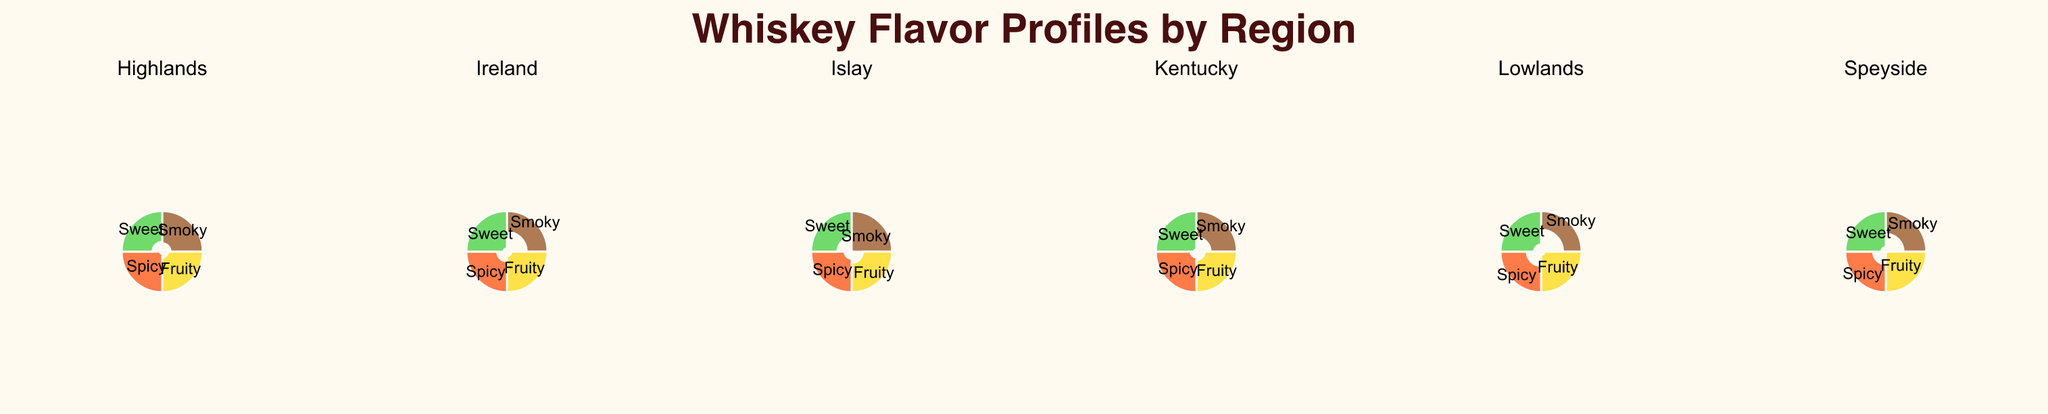Which region has the highest score for the 'Smoky' flavor? By examining the 'Smoky' section in each subplot, the region with the highest radius appears to be Islay with a score of 95.
Answer: Islay Which region shows the most balanced flavor profile, where scores across all flavors are closest to each other? The region with the most balanced flavor profile will have the radii of all flavors closest in length. Upon reviewing the polar charts, Ireland has the most balanced profile with scores relatively close (Smoky: 25, Fruity: 75, Spicy: 55, Sweet: 80).
Answer: Ireland What is the average score for fruity flavors across all regions? First, identify the scores for fruity flavors in each region: Islay: 50, Speyside: 90, Highlands: 70, Lowlands: 80, Kentucky: 60, Ireland: 75. Sum these scores (50 + 90 + 70 + 80 + 60 + 75 = 425). Then, divide by the number of regions (425/6 = 70.83).
Answer: 70.83 Which flavor has the highest average score across all regions? Sum up the scores for each flavor across all regions and divide by the number of regions: Smoky: (95+30+60+20+40+25)/6 = 45, Fruity: (50+90+70+80+60+75)/6 = 70.83, Spicy: (65+45+85+40+70+55)/6 = 60, Sweet: (40+75+55+65+85+80)/6 = 66.67. The highest average is the fruity flavor.
Answer: Fruity Which region has the lowest score for the 'Sweet' flavor? By looking at the 'Sweet' section in each subplot, Islay has the smallest radius for the 'Sweet' flavor with a score of 40.
Answer: Islay What is the total score for the 'Spicy' flavor across all regions? Sum the scores for the 'Spicy' flavor in each region: Islay: 65, Speyside: 45, Highlands: 85, Lowlands: 40, Kentucky: 70, Ireland: 55. The total is 65 + 45 + 85 + 40 + 70 + 55 = 360.
Answer: 360 Which region shows the highest variety in flavor profiles, indicated by the widest range in scores? The variety can be measured by the difference between the highest and lowest scores in each region. Compute the range for each region: Islay (95-40=55), Speyside (90-30=60), Highlands (85-55=30), Lowlands (80-20=60), Kentucky (85-40=45), Ireland (80-25=55). Both Speyside and Lowlands show the highest variety with a range of 60.
Answer: Speyside, Lowlands Which flavor is the least dominant in the Lowlands region? The flavor with the smallest radius in the Lowlands region is 'Smoky' with a score of 20.
Answer: Smoky Which region exhibits the highest sweetness score, and what is it? By examining the 'Sweet' section in each subplot, Kentucky has the highest score with 85.
Answer: Kentucky What is the biggest difference in scores for the 'Spicy' flavor between any two regions? Identify the scores for the 'Spicy' flavor in all regions: Islay: 65, Speyside: 45, Highlands: 85, Lowlands: 40, Kentucky: 70, Ireland: 55. The biggest difference is between Highlands (85) and Lowlands (40), which is 85 - 40 = 45.
Answer: 45 